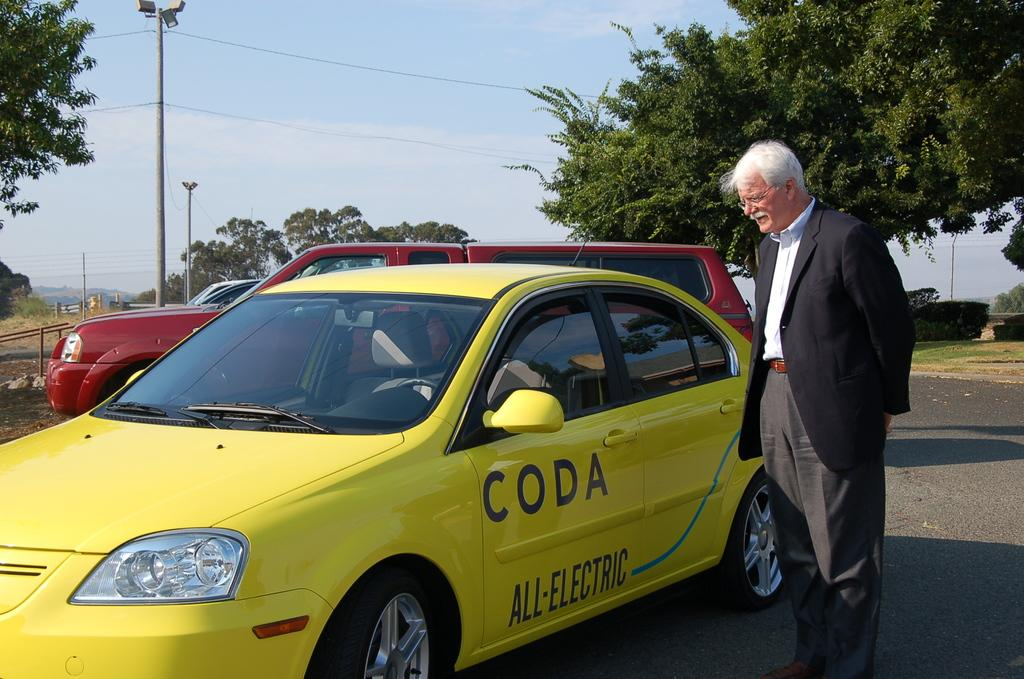<image>
Relay a brief, clear account of the picture shown. An all-electric car has CODA on its driver's door. 